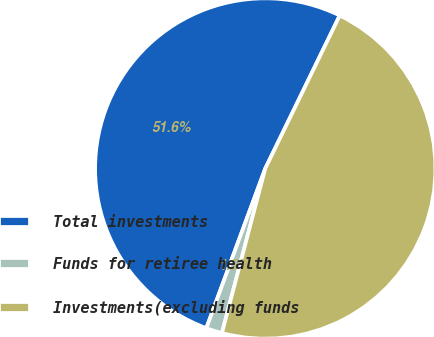<chart> <loc_0><loc_0><loc_500><loc_500><pie_chart><fcel>Total investments<fcel>Funds for retiree health<fcel>Investments(excluding funds<nl><fcel>51.58%<fcel>1.53%<fcel>46.89%<nl></chart> 